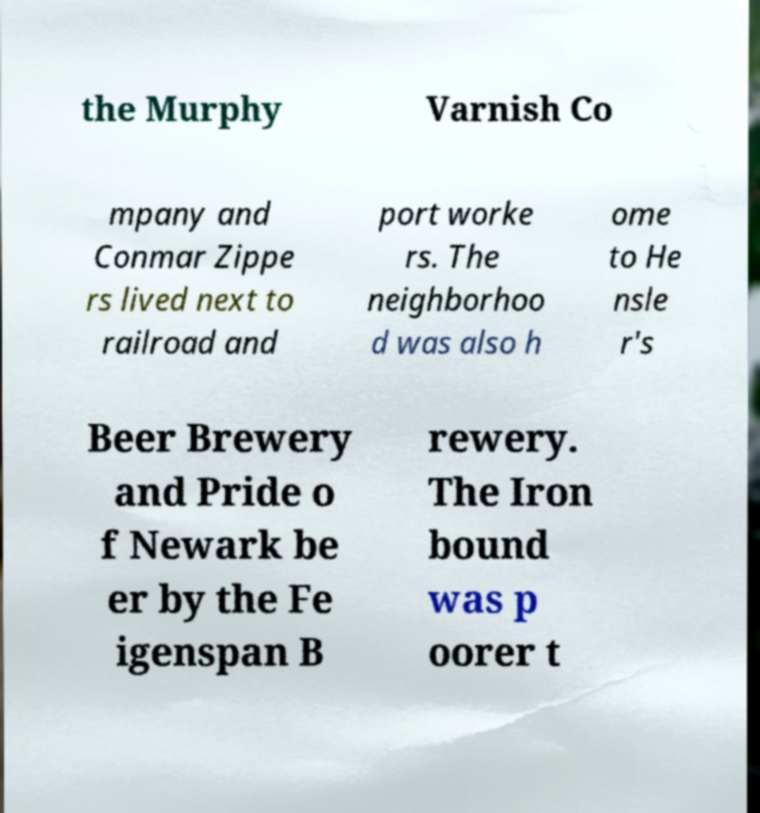What messages or text are displayed in this image? I need them in a readable, typed format. the Murphy Varnish Co mpany and Conmar Zippe rs lived next to railroad and port worke rs. The neighborhoo d was also h ome to He nsle r's Beer Brewery and Pride o f Newark be er by the Fe igenspan B rewery. The Iron bound was p oorer t 